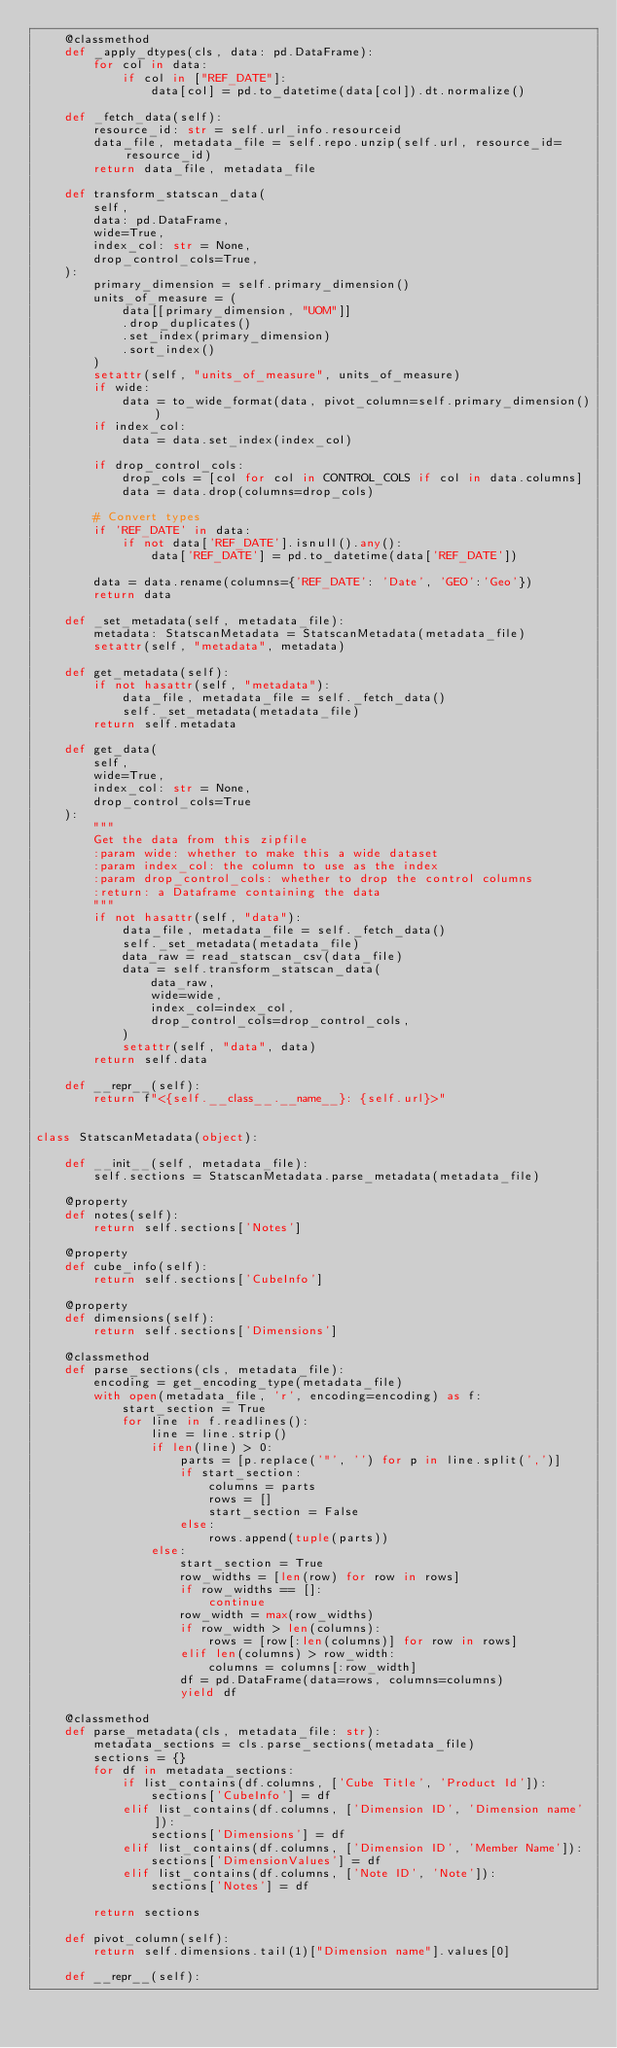Convert code to text. <code><loc_0><loc_0><loc_500><loc_500><_Python_>    @classmethod
    def _apply_dtypes(cls, data: pd.DataFrame):
        for col in data:
            if col in ["REF_DATE"]:
                data[col] = pd.to_datetime(data[col]).dt.normalize()

    def _fetch_data(self):
        resource_id: str = self.url_info.resourceid
        data_file, metadata_file = self.repo.unzip(self.url, resource_id=resource_id)
        return data_file, metadata_file

    def transform_statscan_data(
        self,
        data: pd.DataFrame,
        wide=True,
        index_col: str = None,
        drop_control_cols=True,
    ):
        primary_dimension = self.primary_dimension()
        units_of_measure = (
            data[[primary_dimension, "UOM"]]
            .drop_duplicates()
            .set_index(primary_dimension)
            .sort_index()
        )
        setattr(self, "units_of_measure", units_of_measure)
        if wide:
            data = to_wide_format(data, pivot_column=self.primary_dimension())
        if index_col:
            data = data.set_index(index_col)

        if drop_control_cols:
            drop_cols = [col for col in CONTROL_COLS if col in data.columns]
            data = data.drop(columns=drop_cols)

        # Convert types
        if 'REF_DATE' in data:
            if not data['REF_DATE'].isnull().any():
                data['REF_DATE'] = pd.to_datetime(data['REF_DATE'])

        data = data.rename(columns={'REF_DATE': 'Date', 'GEO':'Geo'})
        return data

    def _set_metadata(self, metadata_file):
        metadata: StatscanMetadata = StatscanMetadata(metadata_file)
        setattr(self, "metadata", metadata)

    def get_metadata(self):
        if not hasattr(self, "metadata"):
            data_file, metadata_file = self._fetch_data()
            self._set_metadata(metadata_file)
        return self.metadata

    def get_data(
        self,
        wide=True,
        index_col: str = None,
        drop_control_cols=True
    ):
        """
        Get the data from this zipfile
        :param wide: whether to make this a wide dataset
        :param index_col: the column to use as the index
        :param drop_control_cols: whether to drop the control columns
        :return: a Dataframe containing the data
        """
        if not hasattr(self, "data"):
            data_file, metadata_file = self._fetch_data()
            self._set_metadata(metadata_file)
            data_raw = read_statscan_csv(data_file)
            data = self.transform_statscan_data(
                data_raw,
                wide=wide,
                index_col=index_col,
                drop_control_cols=drop_control_cols,
            )
            setattr(self, "data", data)
        return self.data

    def __repr__(self):
        return f"<{self.__class__.__name__}: {self.url}>"


class StatscanMetadata(object):

    def __init__(self, metadata_file):
        self.sections = StatscanMetadata.parse_metadata(metadata_file)

    @property
    def notes(self):
        return self.sections['Notes']

    @property
    def cube_info(self):
        return self.sections['CubeInfo']

    @property
    def dimensions(self):
        return self.sections['Dimensions']

    @classmethod
    def parse_sections(cls, metadata_file):
        encoding = get_encoding_type(metadata_file)
        with open(metadata_file, 'r', encoding=encoding) as f:
            start_section = True
            for line in f.readlines():
                line = line.strip()
                if len(line) > 0:
                    parts = [p.replace('"', '') for p in line.split(',')]
                    if start_section:
                        columns = parts
                        rows = []
                        start_section = False
                    else:
                        rows.append(tuple(parts))
                else:
                    start_section = True
                    row_widths = [len(row) for row in rows]
                    if row_widths == []:
                        continue
                    row_width = max(row_widths)
                    if row_width > len(columns):
                        rows = [row[:len(columns)] for row in rows]
                    elif len(columns) > row_width:
                        columns = columns[:row_width]
                    df = pd.DataFrame(data=rows, columns=columns)
                    yield df

    @classmethod
    def parse_metadata(cls, metadata_file: str):
        metadata_sections = cls.parse_sections(metadata_file)
        sections = {}
        for df in metadata_sections:
            if list_contains(df.columns, ['Cube Title', 'Product Id']):
                sections['CubeInfo'] = df
            elif list_contains(df.columns, ['Dimension ID', 'Dimension name']):
                sections['Dimensions'] = df
            elif list_contains(df.columns, ['Dimension ID', 'Member Name']):
                sections['DimensionValues'] = df
            elif list_contains(df.columns, ['Note ID', 'Note']):
                sections['Notes'] = df

        return sections

    def pivot_column(self):
        return self.dimensions.tail(1)["Dimension name"].values[0]

    def __repr__(self):</code> 